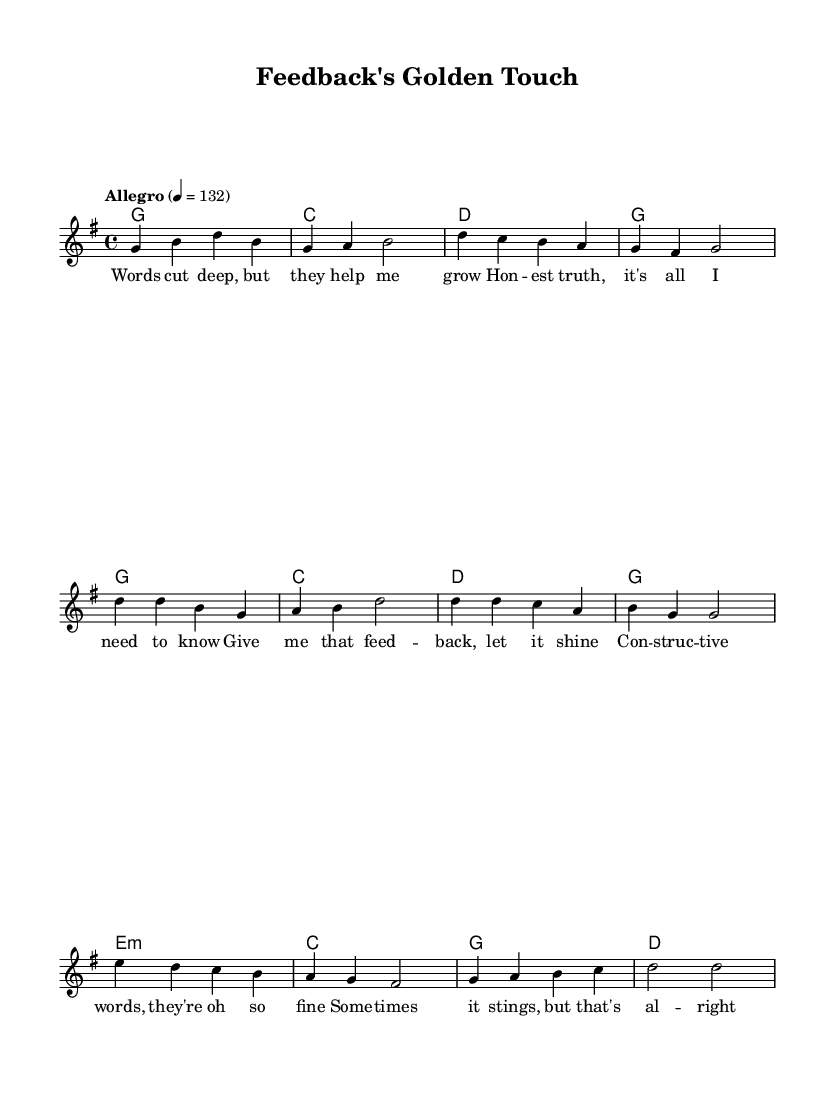What is the key signature of this music? The key signature is G major, which has one sharp (F#). This is indicated at the beginning of the music sheet.
Answer: G major What is the time signature of this music? The time signature is 4/4, indicated by the symbol at the beginning of the music. This means there are four beats in a measure, and each quarter note gets one beat.
Answer: 4/4 What is the tempo marking for this piece? The tempo marking is "Allegro," which indicates a fast and lively pace. This is noted in the tempo indication at the start of the piece.
Answer: Allegro How many measures are there in the verse? There are four measures in the verse, as counted from the melody section where the lyrics align.
Answer: 4 What is the highest note in the melody? The highest note in the melody is D, which appears in multiple places, most notably at the start of the bridge.
Answer: D What do the lyrics in the chorus emphasize? The lyrics in the chorus emphasize the importance of constructive feedback, as indicated by the phrases suggesting that feedback "lets it shine" and that "constructive words" are valuable.
Answer: Constructive feedback Identify the structure of the song. The song follows a verse-chorus-bridge structure, which is common in Country Rock, where the verse presents the theme, the chorus emphasizes it, and the bridge provides a contrast.
Answer: Verse-chorus-bridge 